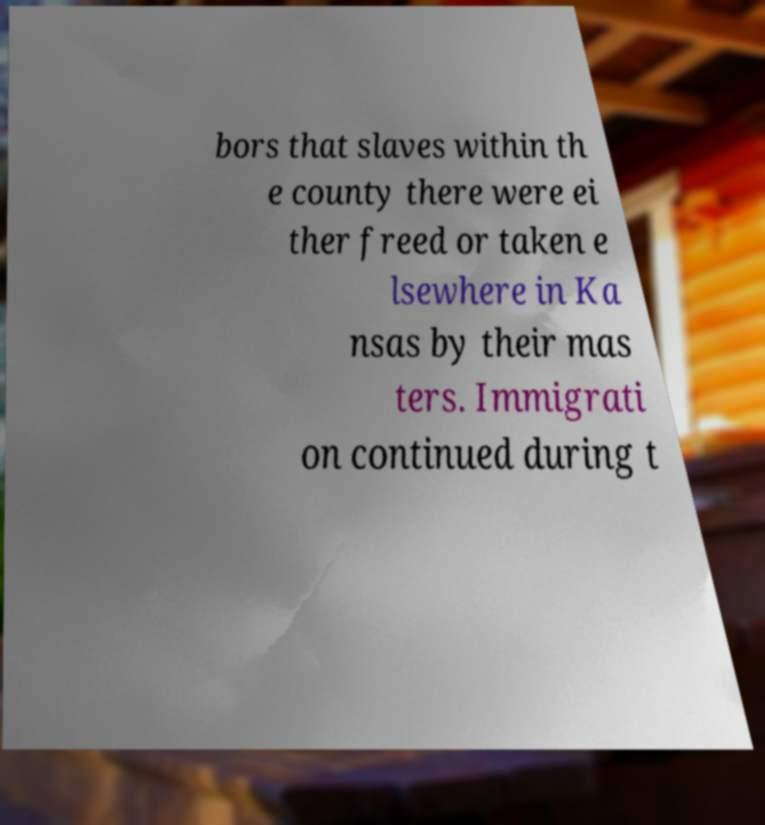There's text embedded in this image that I need extracted. Can you transcribe it verbatim? bors that slaves within th e county there were ei ther freed or taken e lsewhere in Ka nsas by their mas ters. Immigrati on continued during t 